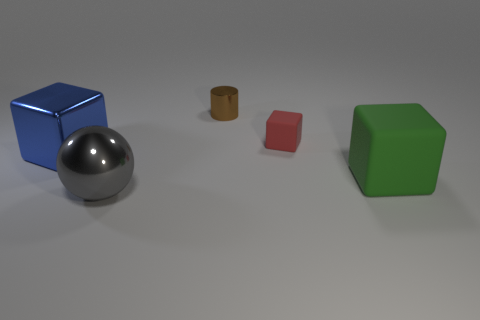Subtract all large blocks. How many blocks are left? 1 Add 1 big yellow metallic cubes. How many objects exist? 6 Subtract all cyan blocks. Subtract all purple cylinders. How many blocks are left? 3 Subtract all cylinders. How many objects are left? 4 Add 2 big blue metallic objects. How many big blue metallic objects exist? 3 Subtract 0 purple balls. How many objects are left? 5 Subtract all tiny rubber objects. Subtract all big shiny blocks. How many objects are left? 3 Add 5 small red matte things. How many small red matte things are left? 6 